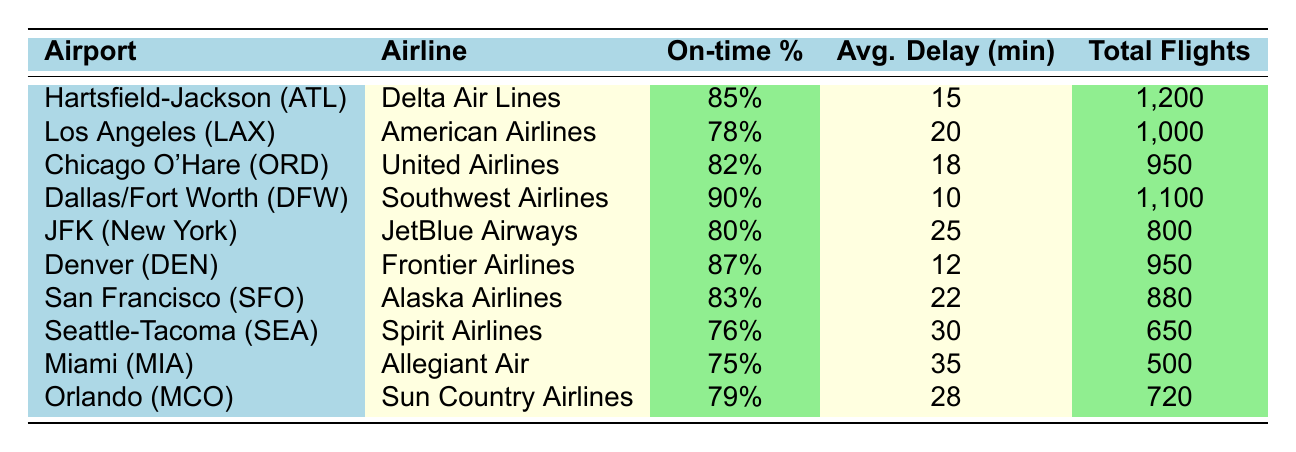What is the on-time percentage for Delta Air Lines at ATL? The table shows that Delta Air Lines has an on-time percentage of 85% at Hartsfield-Jackson Atlanta International Airport (ATL).
Answer: 85% Which airline has the highest average delay in minutes? By comparing the average delay minutes for each airline, Allegiant Air at Miami International Airport (MIA) has the highest average delay of 35 minutes.
Answer: Allegiant Air How many total flights were there for Southwest Airlines at DFW? The table indicates that there were a total of 1,100 flights for Southwest Airlines at Dallas/Fort Worth International Airport (DFW).
Answer: 1,100 What is the average on-time percentage for airlines operating at the airports listed? To find the average on-time percentage, the values (85, 78, 82, 90, 80, 87, 83, 76, 75, 79) should be summed (85 + 78 + 82 + 90 + 80 + 87 + 83 + 76 + 75 + 79 =  84.5) and divided by the total number of airlines (10). The average is 84.5%.
Answer: 84.5% Is Spirit Airlines' on-time performance better than JetBlue Airways'? Spirit Airlines has an on-time percentage of 76%, while JetBlue Airways has 80%. Since 76% is not greater than 80%, the answer is no.
Answer: No Which airport has the best on-time performance and what is the percentage? The table shows that Dallas/Fort Worth International Airport (DFW) has the best on-time performance at 90%.
Answer: 90% at DFW Did United Airlines operate more or fewer total flights than JetBlue Airways? United Airlines operated 950 total flights, while JetBlue Airways operated 800 total flights. Since 950 is greater than 800, the answer is more.
Answer: More What is the difference in on-time percentage between airlines operating at LAX and SEA? American Airlines at LAX has an on-time percentage of 78%, and Spirit Airlines at SEA has 76%. The difference is calculated as 78 - 76 = 2%.
Answer: 2% Which airline has a higher on-time percentage: Alaska Airlines or Southwest Airlines? Alaska Airlines has an on-time percentage of 83% at San Francisco International Airport (SFO) and Southwest Airlines has 90% at Dallas/Fort Worth International Airport (DFW). Because 90% is greater than 83%, Southwest Airlines has the higher percentage.
Answer: Southwest Airlines 